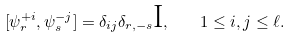Convert formula to latex. <formula><loc_0><loc_0><loc_500><loc_500>[ \psi ^ { + i } _ { r } , \psi ^ { - j } _ { s } ] = \delta _ { i j } \delta _ { r , - s } \text {I} , \quad 1 \leq i , j \leq \ell .</formula> 